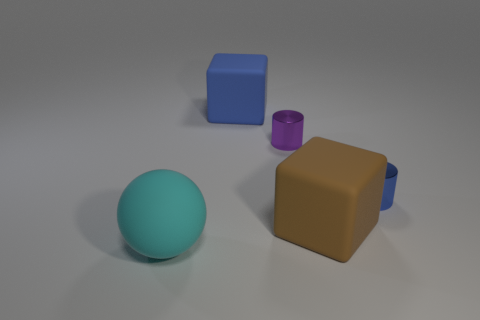Add 4 tiny blue metal things. How many objects exist? 9 Subtract all cubes. How many objects are left? 3 Subtract all cyan cylinders. Subtract all green spheres. How many cylinders are left? 2 Subtract all green cylinders. How many red balls are left? 0 Subtract all cubes. Subtract all tiny red rubber balls. How many objects are left? 3 Add 5 big blue matte cubes. How many big blue matte cubes are left? 6 Add 5 tiny metallic balls. How many tiny metallic balls exist? 5 Subtract 0 blue balls. How many objects are left? 5 Subtract 1 balls. How many balls are left? 0 